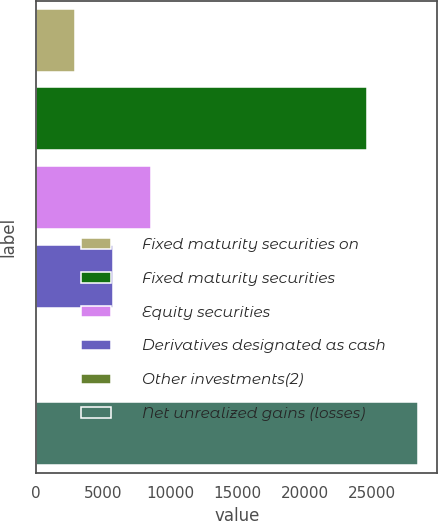<chart> <loc_0><loc_0><loc_500><loc_500><bar_chart><fcel>Fixed maturity securities on<fcel>Fixed maturity securities<fcel>Equity securities<fcel>Derivatives designated as cash<fcel>Other investments(2)<fcel>Net unrealized gains (losses)<nl><fcel>2869.9<fcel>24673<fcel>8559.7<fcel>5714.8<fcel>25<fcel>28474<nl></chart> 